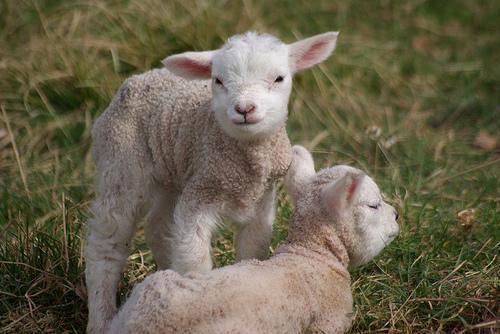How many lambs are visible?
Give a very brief answer. 2. How many lamb ears are visible?
Give a very brief answer. 4. How many lambs are laying down?
Give a very brief answer. 1. 